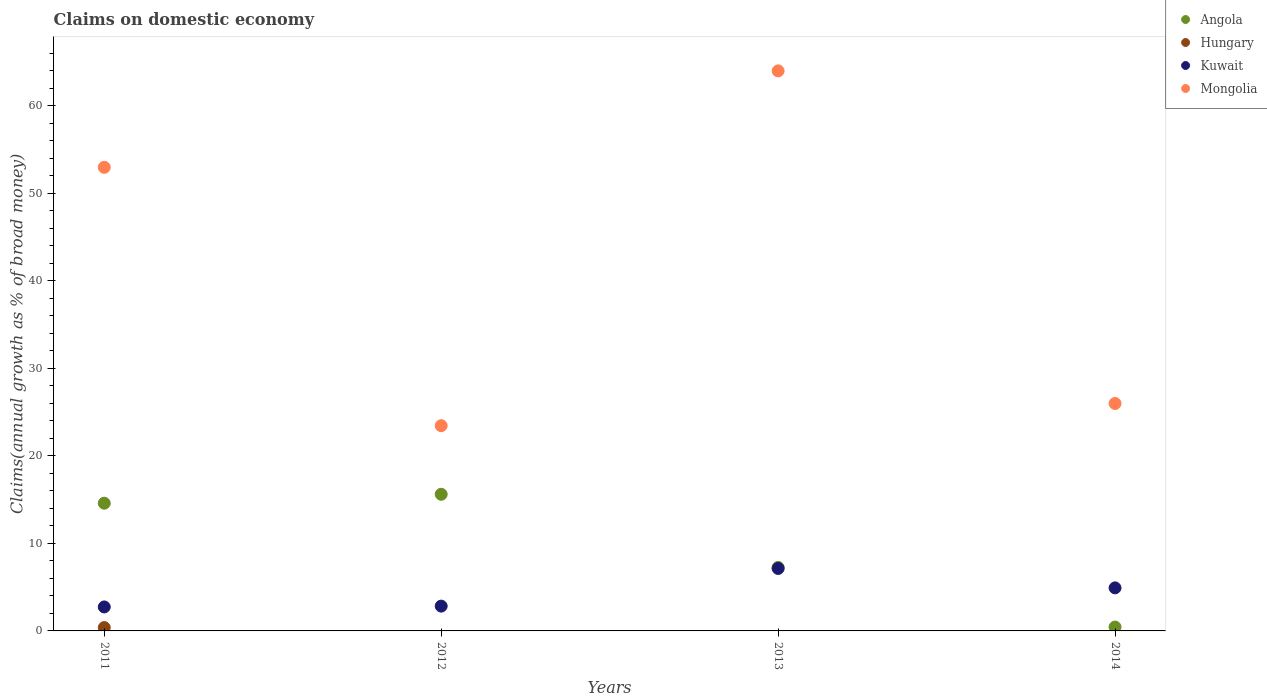Is the number of dotlines equal to the number of legend labels?
Your answer should be compact. No. What is the percentage of broad money claimed on domestic economy in Angola in 2014?
Offer a terse response. 0.45. Across all years, what is the maximum percentage of broad money claimed on domestic economy in Kuwait?
Your answer should be compact. 7.14. Across all years, what is the minimum percentage of broad money claimed on domestic economy in Hungary?
Ensure brevity in your answer.  0. In which year was the percentage of broad money claimed on domestic economy in Mongolia maximum?
Give a very brief answer. 2013. What is the total percentage of broad money claimed on domestic economy in Angola in the graph?
Offer a terse response. 37.92. What is the difference between the percentage of broad money claimed on domestic economy in Angola in 2011 and that in 2014?
Offer a very short reply. 14.15. What is the difference between the percentage of broad money claimed on domestic economy in Hungary in 2011 and the percentage of broad money claimed on domestic economy in Kuwait in 2013?
Your answer should be compact. -6.75. What is the average percentage of broad money claimed on domestic economy in Kuwait per year?
Keep it short and to the point. 4.41. In the year 2013, what is the difference between the percentage of broad money claimed on domestic economy in Kuwait and percentage of broad money claimed on domestic economy in Angola?
Your answer should be very brief. -0.12. In how many years, is the percentage of broad money claimed on domestic economy in Hungary greater than 28 %?
Offer a terse response. 0. What is the ratio of the percentage of broad money claimed on domestic economy in Mongolia in 2012 to that in 2013?
Your answer should be compact. 0.37. What is the difference between the highest and the second highest percentage of broad money claimed on domestic economy in Angola?
Offer a very short reply. 1.02. What is the difference between the highest and the lowest percentage of broad money claimed on domestic economy in Hungary?
Offer a terse response. 0.38. Is the sum of the percentage of broad money claimed on domestic economy in Kuwait in 2011 and 2012 greater than the maximum percentage of broad money claimed on domestic economy in Hungary across all years?
Keep it short and to the point. Yes. Is it the case that in every year, the sum of the percentage of broad money claimed on domestic economy in Hungary and percentage of broad money claimed on domestic economy in Angola  is greater than the percentage of broad money claimed on domestic economy in Mongolia?
Make the answer very short. No. Does the percentage of broad money claimed on domestic economy in Hungary monotonically increase over the years?
Keep it short and to the point. No. Is the percentage of broad money claimed on domestic economy in Kuwait strictly greater than the percentage of broad money claimed on domestic economy in Hungary over the years?
Offer a very short reply. Yes. Is the percentage of broad money claimed on domestic economy in Mongolia strictly less than the percentage of broad money claimed on domestic economy in Angola over the years?
Offer a very short reply. No. How many years are there in the graph?
Make the answer very short. 4. What is the difference between two consecutive major ticks on the Y-axis?
Ensure brevity in your answer.  10. Does the graph contain any zero values?
Offer a very short reply. Yes. Does the graph contain grids?
Give a very brief answer. No. How many legend labels are there?
Offer a terse response. 4. How are the legend labels stacked?
Your answer should be compact. Vertical. What is the title of the graph?
Give a very brief answer. Claims on domestic economy. Does "Euro area" appear as one of the legend labels in the graph?
Your answer should be compact. No. What is the label or title of the X-axis?
Provide a succinct answer. Years. What is the label or title of the Y-axis?
Ensure brevity in your answer.  Claims(annual growth as % of broad money). What is the Claims(annual growth as % of broad money) in Angola in 2011?
Your answer should be compact. 14.6. What is the Claims(annual growth as % of broad money) of Hungary in 2011?
Ensure brevity in your answer.  0.38. What is the Claims(annual growth as % of broad money) of Kuwait in 2011?
Provide a short and direct response. 2.74. What is the Claims(annual growth as % of broad money) in Mongolia in 2011?
Give a very brief answer. 52.99. What is the Claims(annual growth as % of broad money) in Angola in 2012?
Your answer should be compact. 15.62. What is the Claims(annual growth as % of broad money) of Hungary in 2012?
Your answer should be very brief. 0. What is the Claims(annual growth as % of broad money) in Kuwait in 2012?
Provide a short and direct response. 2.83. What is the Claims(annual growth as % of broad money) of Mongolia in 2012?
Offer a terse response. 23.46. What is the Claims(annual growth as % of broad money) in Angola in 2013?
Offer a very short reply. 7.26. What is the Claims(annual growth as % of broad money) in Hungary in 2013?
Ensure brevity in your answer.  0. What is the Claims(annual growth as % of broad money) of Kuwait in 2013?
Keep it short and to the point. 7.14. What is the Claims(annual growth as % of broad money) in Mongolia in 2013?
Your answer should be very brief. 64.01. What is the Claims(annual growth as % of broad money) of Angola in 2014?
Offer a very short reply. 0.45. What is the Claims(annual growth as % of broad money) of Hungary in 2014?
Provide a succinct answer. 0. What is the Claims(annual growth as % of broad money) of Kuwait in 2014?
Keep it short and to the point. 4.92. What is the Claims(annual growth as % of broad money) in Mongolia in 2014?
Offer a very short reply. 26. Across all years, what is the maximum Claims(annual growth as % of broad money) of Angola?
Make the answer very short. 15.62. Across all years, what is the maximum Claims(annual growth as % of broad money) of Hungary?
Provide a succinct answer. 0.38. Across all years, what is the maximum Claims(annual growth as % of broad money) in Kuwait?
Provide a short and direct response. 7.14. Across all years, what is the maximum Claims(annual growth as % of broad money) in Mongolia?
Keep it short and to the point. 64.01. Across all years, what is the minimum Claims(annual growth as % of broad money) of Angola?
Your answer should be very brief. 0.45. Across all years, what is the minimum Claims(annual growth as % of broad money) of Kuwait?
Provide a succinct answer. 2.74. Across all years, what is the minimum Claims(annual growth as % of broad money) in Mongolia?
Give a very brief answer. 23.46. What is the total Claims(annual growth as % of broad money) of Angola in the graph?
Give a very brief answer. 37.92. What is the total Claims(annual growth as % of broad money) in Hungary in the graph?
Make the answer very short. 0.38. What is the total Claims(annual growth as % of broad money) in Kuwait in the graph?
Your answer should be very brief. 17.63. What is the total Claims(annual growth as % of broad money) in Mongolia in the graph?
Your response must be concise. 166.45. What is the difference between the Claims(annual growth as % of broad money) of Angola in 2011 and that in 2012?
Give a very brief answer. -1.02. What is the difference between the Claims(annual growth as % of broad money) in Kuwait in 2011 and that in 2012?
Ensure brevity in your answer.  -0.09. What is the difference between the Claims(annual growth as % of broad money) in Mongolia in 2011 and that in 2012?
Offer a very short reply. 29.53. What is the difference between the Claims(annual growth as % of broad money) of Angola in 2011 and that in 2013?
Your answer should be compact. 7.34. What is the difference between the Claims(annual growth as % of broad money) of Kuwait in 2011 and that in 2013?
Your answer should be compact. -4.4. What is the difference between the Claims(annual growth as % of broad money) of Mongolia in 2011 and that in 2013?
Your answer should be very brief. -11.02. What is the difference between the Claims(annual growth as % of broad money) of Angola in 2011 and that in 2014?
Your answer should be very brief. 14.15. What is the difference between the Claims(annual growth as % of broad money) of Kuwait in 2011 and that in 2014?
Make the answer very short. -2.18. What is the difference between the Claims(annual growth as % of broad money) in Mongolia in 2011 and that in 2014?
Your answer should be very brief. 26.99. What is the difference between the Claims(annual growth as % of broad money) in Angola in 2012 and that in 2013?
Your response must be concise. 8.36. What is the difference between the Claims(annual growth as % of broad money) of Kuwait in 2012 and that in 2013?
Your answer should be very brief. -4.3. What is the difference between the Claims(annual growth as % of broad money) of Mongolia in 2012 and that in 2013?
Keep it short and to the point. -40.55. What is the difference between the Claims(annual growth as % of broad money) in Angola in 2012 and that in 2014?
Provide a short and direct response. 15.17. What is the difference between the Claims(annual growth as % of broad money) of Kuwait in 2012 and that in 2014?
Your answer should be very brief. -2.09. What is the difference between the Claims(annual growth as % of broad money) in Mongolia in 2012 and that in 2014?
Provide a succinct answer. -2.54. What is the difference between the Claims(annual growth as % of broad money) in Angola in 2013 and that in 2014?
Offer a very short reply. 6.81. What is the difference between the Claims(annual growth as % of broad money) in Kuwait in 2013 and that in 2014?
Provide a short and direct response. 2.22. What is the difference between the Claims(annual growth as % of broad money) in Mongolia in 2013 and that in 2014?
Your response must be concise. 38.01. What is the difference between the Claims(annual growth as % of broad money) of Angola in 2011 and the Claims(annual growth as % of broad money) of Kuwait in 2012?
Your response must be concise. 11.76. What is the difference between the Claims(annual growth as % of broad money) in Angola in 2011 and the Claims(annual growth as % of broad money) in Mongolia in 2012?
Offer a terse response. -8.86. What is the difference between the Claims(annual growth as % of broad money) in Hungary in 2011 and the Claims(annual growth as % of broad money) in Kuwait in 2012?
Keep it short and to the point. -2.45. What is the difference between the Claims(annual growth as % of broad money) in Hungary in 2011 and the Claims(annual growth as % of broad money) in Mongolia in 2012?
Offer a very short reply. -23.07. What is the difference between the Claims(annual growth as % of broad money) of Kuwait in 2011 and the Claims(annual growth as % of broad money) of Mongolia in 2012?
Provide a short and direct response. -20.72. What is the difference between the Claims(annual growth as % of broad money) in Angola in 2011 and the Claims(annual growth as % of broad money) in Kuwait in 2013?
Ensure brevity in your answer.  7.46. What is the difference between the Claims(annual growth as % of broad money) in Angola in 2011 and the Claims(annual growth as % of broad money) in Mongolia in 2013?
Your answer should be very brief. -49.41. What is the difference between the Claims(annual growth as % of broad money) of Hungary in 2011 and the Claims(annual growth as % of broad money) of Kuwait in 2013?
Provide a succinct answer. -6.75. What is the difference between the Claims(annual growth as % of broad money) of Hungary in 2011 and the Claims(annual growth as % of broad money) of Mongolia in 2013?
Your answer should be compact. -63.63. What is the difference between the Claims(annual growth as % of broad money) of Kuwait in 2011 and the Claims(annual growth as % of broad money) of Mongolia in 2013?
Your response must be concise. -61.27. What is the difference between the Claims(annual growth as % of broad money) in Angola in 2011 and the Claims(annual growth as % of broad money) in Kuwait in 2014?
Make the answer very short. 9.68. What is the difference between the Claims(annual growth as % of broad money) of Angola in 2011 and the Claims(annual growth as % of broad money) of Mongolia in 2014?
Provide a succinct answer. -11.4. What is the difference between the Claims(annual growth as % of broad money) of Hungary in 2011 and the Claims(annual growth as % of broad money) of Kuwait in 2014?
Provide a short and direct response. -4.54. What is the difference between the Claims(annual growth as % of broad money) of Hungary in 2011 and the Claims(annual growth as % of broad money) of Mongolia in 2014?
Ensure brevity in your answer.  -25.61. What is the difference between the Claims(annual growth as % of broad money) in Kuwait in 2011 and the Claims(annual growth as % of broad money) in Mongolia in 2014?
Give a very brief answer. -23.26. What is the difference between the Claims(annual growth as % of broad money) of Angola in 2012 and the Claims(annual growth as % of broad money) of Kuwait in 2013?
Make the answer very short. 8.48. What is the difference between the Claims(annual growth as % of broad money) of Angola in 2012 and the Claims(annual growth as % of broad money) of Mongolia in 2013?
Offer a terse response. -48.39. What is the difference between the Claims(annual growth as % of broad money) in Kuwait in 2012 and the Claims(annual growth as % of broad money) in Mongolia in 2013?
Offer a very short reply. -61.18. What is the difference between the Claims(annual growth as % of broad money) of Angola in 2012 and the Claims(annual growth as % of broad money) of Kuwait in 2014?
Make the answer very short. 10.7. What is the difference between the Claims(annual growth as % of broad money) in Angola in 2012 and the Claims(annual growth as % of broad money) in Mongolia in 2014?
Provide a short and direct response. -10.38. What is the difference between the Claims(annual growth as % of broad money) of Kuwait in 2012 and the Claims(annual growth as % of broad money) of Mongolia in 2014?
Offer a terse response. -23.16. What is the difference between the Claims(annual growth as % of broad money) in Angola in 2013 and the Claims(annual growth as % of broad money) in Kuwait in 2014?
Your response must be concise. 2.34. What is the difference between the Claims(annual growth as % of broad money) in Angola in 2013 and the Claims(annual growth as % of broad money) in Mongolia in 2014?
Provide a short and direct response. -18.74. What is the difference between the Claims(annual growth as % of broad money) in Kuwait in 2013 and the Claims(annual growth as % of broad money) in Mongolia in 2014?
Provide a short and direct response. -18.86. What is the average Claims(annual growth as % of broad money) of Angola per year?
Offer a terse response. 9.48. What is the average Claims(annual growth as % of broad money) in Hungary per year?
Provide a succinct answer. 0.1. What is the average Claims(annual growth as % of broad money) of Kuwait per year?
Make the answer very short. 4.41. What is the average Claims(annual growth as % of broad money) in Mongolia per year?
Offer a terse response. 41.61. In the year 2011, what is the difference between the Claims(annual growth as % of broad money) of Angola and Claims(annual growth as % of broad money) of Hungary?
Provide a short and direct response. 14.21. In the year 2011, what is the difference between the Claims(annual growth as % of broad money) in Angola and Claims(annual growth as % of broad money) in Kuwait?
Keep it short and to the point. 11.86. In the year 2011, what is the difference between the Claims(annual growth as % of broad money) in Angola and Claims(annual growth as % of broad money) in Mongolia?
Ensure brevity in your answer.  -38.39. In the year 2011, what is the difference between the Claims(annual growth as % of broad money) of Hungary and Claims(annual growth as % of broad money) of Kuwait?
Your answer should be very brief. -2.36. In the year 2011, what is the difference between the Claims(annual growth as % of broad money) of Hungary and Claims(annual growth as % of broad money) of Mongolia?
Offer a terse response. -52.6. In the year 2011, what is the difference between the Claims(annual growth as % of broad money) in Kuwait and Claims(annual growth as % of broad money) in Mongolia?
Give a very brief answer. -50.25. In the year 2012, what is the difference between the Claims(annual growth as % of broad money) in Angola and Claims(annual growth as % of broad money) in Kuwait?
Your response must be concise. 12.78. In the year 2012, what is the difference between the Claims(annual growth as % of broad money) in Angola and Claims(annual growth as % of broad money) in Mongolia?
Your response must be concise. -7.84. In the year 2012, what is the difference between the Claims(annual growth as % of broad money) of Kuwait and Claims(annual growth as % of broad money) of Mongolia?
Give a very brief answer. -20.62. In the year 2013, what is the difference between the Claims(annual growth as % of broad money) in Angola and Claims(annual growth as % of broad money) in Kuwait?
Provide a succinct answer. 0.12. In the year 2013, what is the difference between the Claims(annual growth as % of broad money) of Angola and Claims(annual growth as % of broad money) of Mongolia?
Provide a short and direct response. -56.75. In the year 2013, what is the difference between the Claims(annual growth as % of broad money) of Kuwait and Claims(annual growth as % of broad money) of Mongolia?
Ensure brevity in your answer.  -56.87. In the year 2014, what is the difference between the Claims(annual growth as % of broad money) of Angola and Claims(annual growth as % of broad money) of Kuwait?
Offer a very short reply. -4.47. In the year 2014, what is the difference between the Claims(annual growth as % of broad money) of Angola and Claims(annual growth as % of broad money) of Mongolia?
Your answer should be very brief. -25.55. In the year 2014, what is the difference between the Claims(annual growth as % of broad money) of Kuwait and Claims(annual growth as % of broad money) of Mongolia?
Make the answer very short. -21.08. What is the ratio of the Claims(annual growth as % of broad money) in Angola in 2011 to that in 2012?
Give a very brief answer. 0.93. What is the ratio of the Claims(annual growth as % of broad money) in Kuwait in 2011 to that in 2012?
Provide a succinct answer. 0.97. What is the ratio of the Claims(annual growth as % of broad money) in Mongolia in 2011 to that in 2012?
Offer a terse response. 2.26. What is the ratio of the Claims(annual growth as % of broad money) of Angola in 2011 to that in 2013?
Provide a short and direct response. 2.01. What is the ratio of the Claims(annual growth as % of broad money) of Kuwait in 2011 to that in 2013?
Give a very brief answer. 0.38. What is the ratio of the Claims(annual growth as % of broad money) of Mongolia in 2011 to that in 2013?
Give a very brief answer. 0.83. What is the ratio of the Claims(annual growth as % of broad money) of Angola in 2011 to that in 2014?
Ensure brevity in your answer.  32.74. What is the ratio of the Claims(annual growth as % of broad money) in Kuwait in 2011 to that in 2014?
Your answer should be compact. 0.56. What is the ratio of the Claims(annual growth as % of broad money) of Mongolia in 2011 to that in 2014?
Your response must be concise. 2.04. What is the ratio of the Claims(annual growth as % of broad money) in Angola in 2012 to that in 2013?
Make the answer very short. 2.15. What is the ratio of the Claims(annual growth as % of broad money) in Kuwait in 2012 to that in 2013?
Your answer should be very brief. 0.4. What is the ratio of the Claims(annual growth as % of broad money) in Mongolia in 2012 to that in 2013?
Provide a succinct answer. 0.37. What is the ratio of the Claims(annual growth as % of broad money) of Angola in 2012 to that in 2014?
Your response must be concise. 35.02. What is the ratio of the Claims(annual growth as % of broad money) of Kuwait in 2012 to that in 2014?
Make the answer very short. 0.58. What is the ratio of the Claims(annual growth as % of broad money) in Mongolia in 2012 to that in 2014?
Offer a terse response. 0.9. What is the ratio of the Claims(annual growth as % of broad money) of Angola in 2013 to that in 2014?
Give a very brief answer. 16.28. What is the ratio of the Claims(annual growth as % of broad money) of Kuwait in 2013 to that in 2014?
Provide a succinct answer. 1.45. What is the ratio of the Claims(annual growth as % of broad money) of Mongolia in 2013 to that in 2014?
Provide a short and direct response. 2.46. What is the difference between the highest and the second highest Claims(annual growth as % of broad money) of Angola?
Your answer should be compact. 1.02. What is the difference between the highest and the second highest Claims(annual growth as % of broad money) in Kuwait?
Your answer should be very brief. 2.22. What is the difference between the highest and the second highest Claims(annual growth as % of broad money) of Mongolia?
Provide a short and direct response. 11.02. What is the difference between the highest and the lowest Claims(annual growth as % of broad money) of Angola?
Give a very brief answer. 15.17. What is the difference between the highest and the lowest Claims(annual growth as % of broad money) of Hungary?
Offer a very short reply. 0.38. What is the difference between the highest and the lowest Claims(annual growth as % of broad money) in Kuwait?
Provide a short and direct response. 4.4. What is the difference between the highest and the lowest Claims(annual growth as % of broad money) of Mongolia?
Your response must be concise. 40.55. 